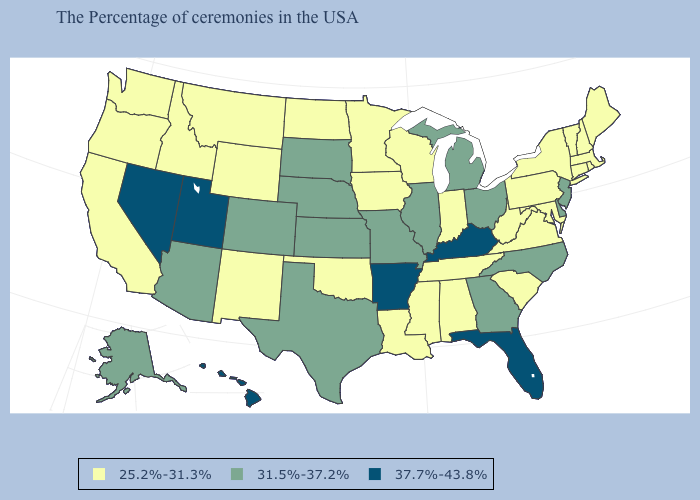What is the lowest value in the USA?
Concise answer only. 25.2%-31.3%. What is the value of Texas?
Give a very brief answer. 31.5%-37.2%. Among the states that border Arizona , which have the highest value?
Write a very short answer. Utah, Nevada. How many symbols are there in the legend?
Quick response, please. 3. Among the states that border Arkansas , does Missouri have the lowest value?
Short answer required. No. Which states hav the highest value in the West?
Give a very brief answer. Utah, Nevada, Hawaii. Does Louisiana have the highest value in the South?
Quick response, please. No. Does North Carolina have the lowest value in the USA?
Give a very brief answer. No. Name the states that have a value in the range 25.2%-31.3%?
Short answer required. Maine, Massachusetts, Rhode Island, New Hampshire, Vermont, Connecticut, New York, Maryland, Pennsylvania, Virginia, South Carolina, West Virginia, Indiana, Alabama, Tennessee, Wisconsin, Mississippi, Louisiana, Minnesota, Iowa, Oklahoma, North Dakota, Wyoming, New Mexico, Montana, Idaho, California, Washington, Oregon. Name the states that have a value in the range 31.5%-37.2%?
Concise answer only. New Jersey, Delaware, North Carolina, Ohio, Georgia, Michigan, Illinois, Missouri, Kansas, Nebraska, Texas, South Dakota, Colorado, Arizona, Alaska. Does the map have missing data?
Write a very short answer. No. What is the value of Wisconsin?
Quick response, please. 25.2%-31.3%. Name the states that have a value in the range 37.7%-43.8%?
Give a very brief answer. Florida, Kentucky, Arkansas, Utah, Nevada, Hawaii. What is the value of New Hampshire?
Keep it brief. 25.2%-31.3%. What is the value of Kentucky?
Answer briefly. 37.7%-43.8%. 